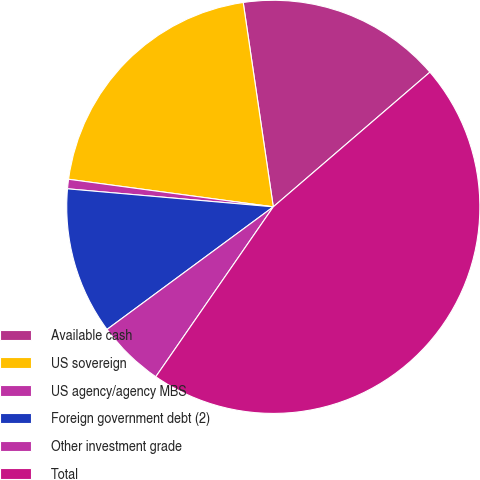Convert chart to OTSL. <chart><loc_0><loc_0><loc_500><loc_500><pie_chart><fcel>Available cash<fcel>US sovereign<fcel>US agency/agency MBS<fcel>Foreign government debt (2)<fcel>Other investment grade<fcel>Total<nl><fcel>16.02%<fcel>20.54%<fcel>0.74%<fcel>11.5%<fcel>5.26%<fcel>45.93%<nl></chart> 